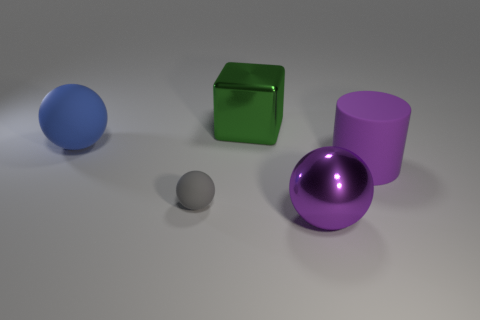Subtract all big spheres. How many spheres are left? 1 Add 3 rubber cylinders. How many objects exist? 8 Subtract all purple balls. How many balls are left? 2 Subtract all spheres. How many objects are left? 2 Subtract 2 spheres. How many spheres are left? 1 Subtract all blue cylinders. Subtract all gray cubes. How many cylinders are left? 1 Subtract all purple spheres. How many green cylinders are left? 0 Subtract all purple metallic cubes. Subtract all rubber things. How many objects are left? 2 Add 1 large cylinders. How many large cylinders are left? 2 Add 4 green metal objects. How many green metal objects exist? 5 